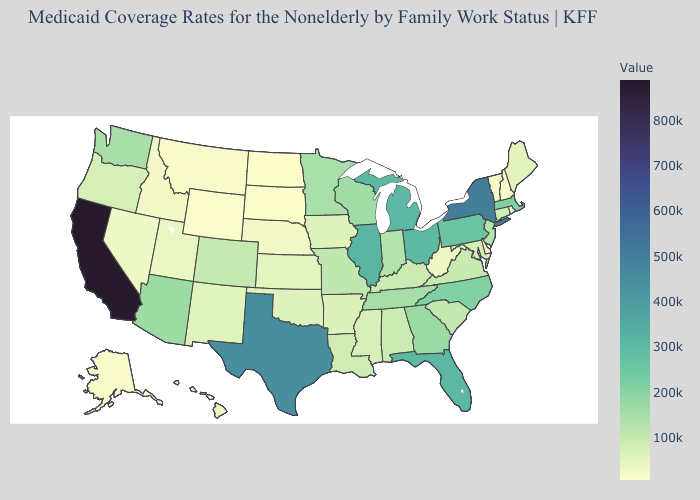Does Florida have the highest value in the USA?
Concise answer only. No. Does the map have missing data?
Be succinct. No. Does the map have missing data?
Answer briefly. No. 